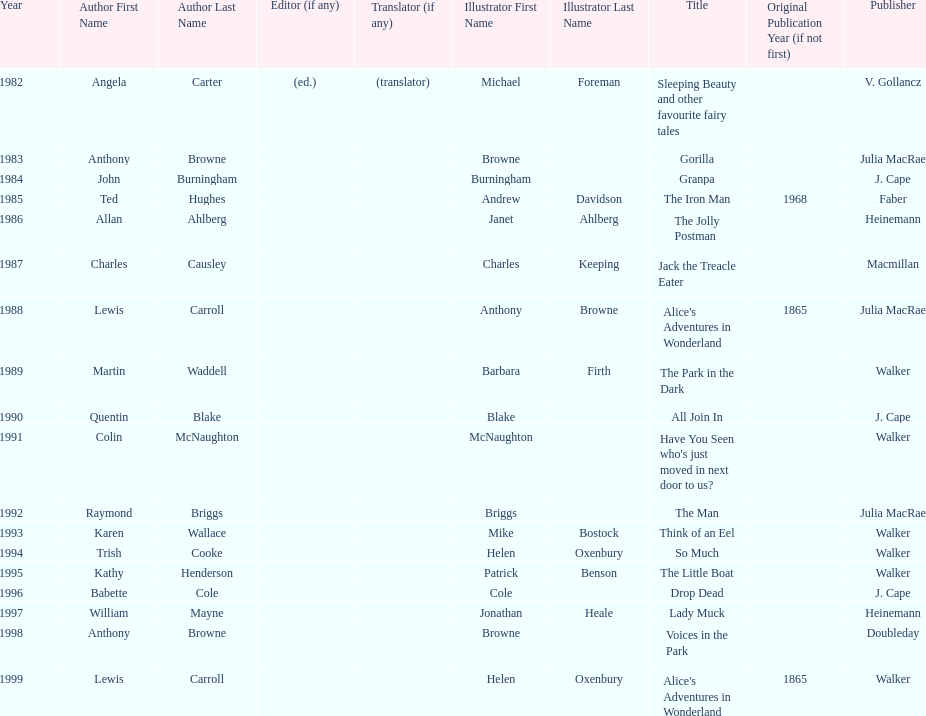Which other author, besides lewis carroll, has won the kurt maschler award twice? Anthony Browne. 